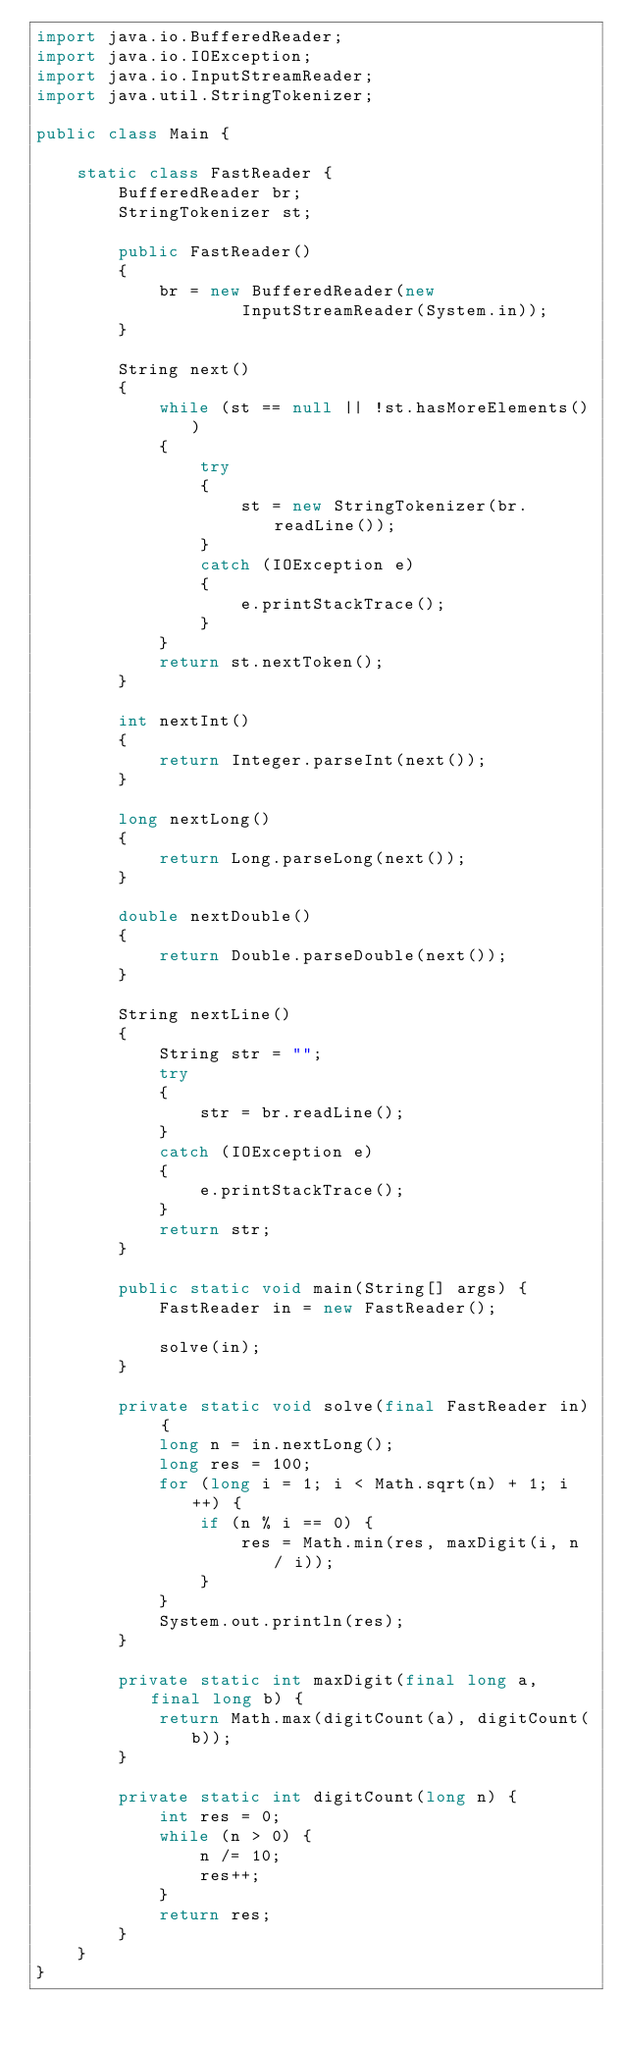Convert code to text. <code><loc_0><loc_0><loc_500><loc_500><_Java_>import java.io.BufferedReader;
import java.io.IOException;
import java.io.InputStreamReader;
import java.util.StringTokenizer;

public class Main {

    static class FastReader {
        BufferedReader br;
        StringTokenizer st;

        public FastReader()
        {
            br = new BufferedReader(new
                    InputStreamReader(System.in));
        }

        String next()
        {
            while (st == null || !st.hasMoreElements())
            {
                try
                {
                    st = new StringTokenizer(br.readLine());
                }
                catch (IOException e)
                {
                    e.printStackTrace();
                }
            }
            return st.nextToken();
        }

        int nextInt()
        {
            return Integer.parseInt(next());
        }

        long nextLong()
        {
            return Long.parseLong(next());
        }

        double nextDouble()
        {
            return Double.parseDouble(next());
        }

        String nextLine()
        {
            String str = "";
            try
            {
                str = br.readLine();
            }
            catch (IOException e)
            {
                e.printStackTrace();
            }
            return str;
        }

        public static void main(String[] args) {
            FastReader in = new FastReader();

            solve(in);
        }

        private static void solve(final FastReader in) {
            long n = in.nextLong();
            long res = 100;
            for (long i = 1; i < Math.sqrt(n) + 1; i++) {
                if (n % i == 0) {
                    res = Math.min(res, maxDigit(i, n / i));
                }
            }
            System.out.println(res);
        }

        private static int maxDigit(final long a, final long b) {
            return Math.max(digitCount(a), digitCount(b));
        }

        private static int digitCount(long n) {
            int res = 0;
            while (n > 0) {
                n /= 10;
                res++;
            }
            return res;
        }
    }
}
</code> 